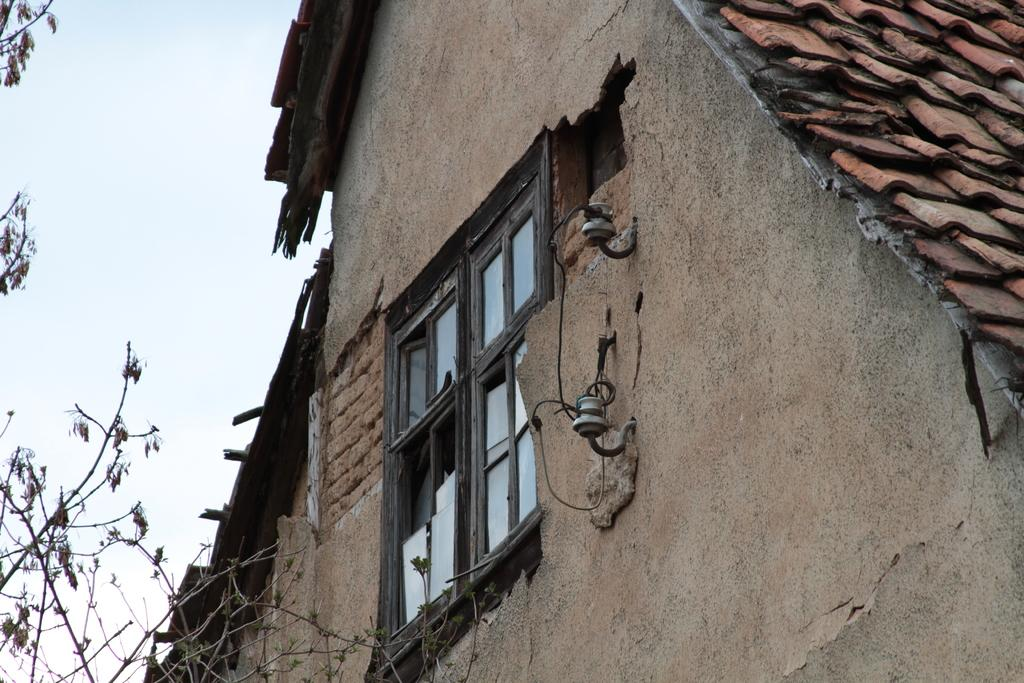What type of structure is in the image? There is a house in the image. What feature can be seen on the house? The house has a window. What type of vegetation is in the image? There is a tree in the image. What is visible in the background of the image? The sky is visible in the background of the image. How many toes are visible in the image? There are no toes visible in the image. 